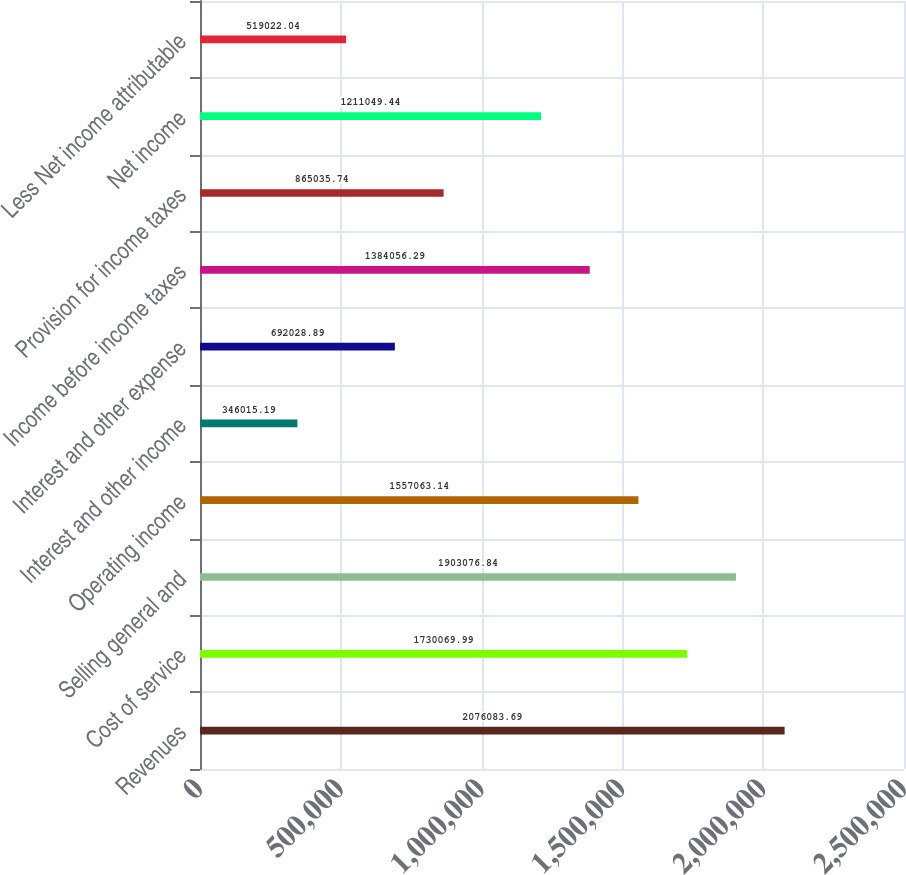Convert chart. <chart><loc_0><loc_0><loc_500><loc_500><bar_chart><fcel>Revenues<fcel>Cost of service<fcel>Selling general and<fcel>Operating income<fcel>Interest and other income<fcel>Interest and other expense<fcel>Income before income taxes<fcel>Provision for income taxes<fcel>Net income<fcel>Less Net income attributable<nl><fcel>2.07608e+06<fcel>1.73007e+06<fcel>1.90308e+06<fcel>1.55706e+06<fcel>346015<fcel>692029<fcel>1.38406e+06<fcel>865036<fcel>1.21105e+06<fcel>519022<nl></chart> 